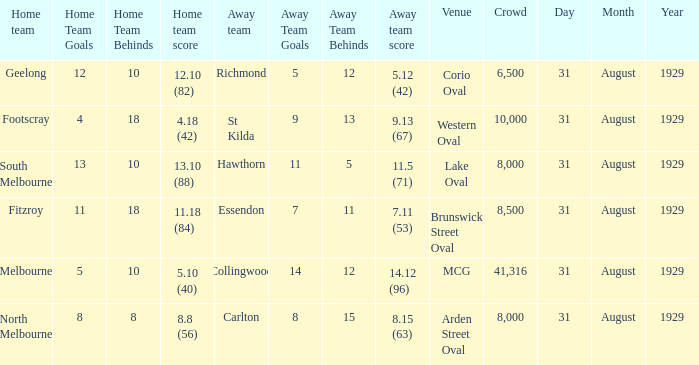What is the largest crowd when the away team is Hawthorn? 8000.0. 